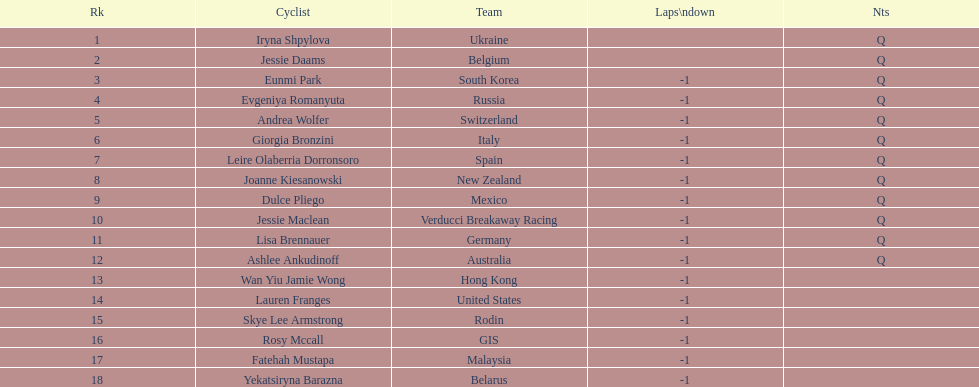How many consecutive notes are there? 12. 